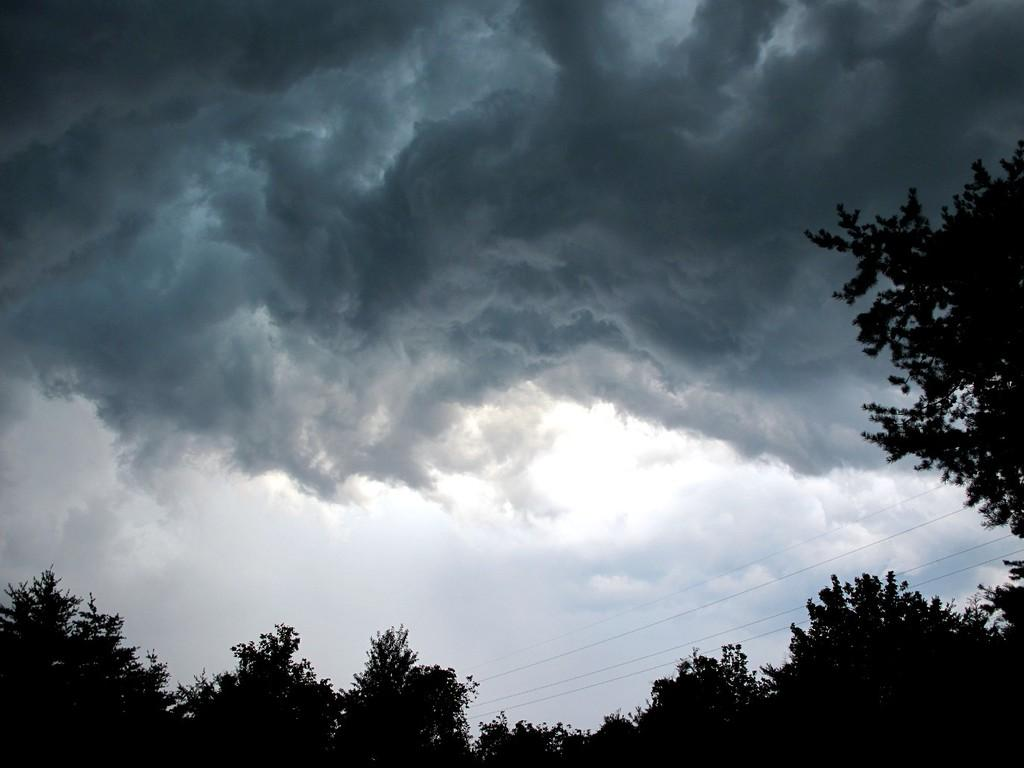What can be seen in the sky in the image? The sky is visible in the image, and there are clouds present. What else is visible in the image besides the sky? Wires and trees are visible in the image. What type of society does the grandfather represent in the image? There is no grandfather or any representation of a society present in the image. 